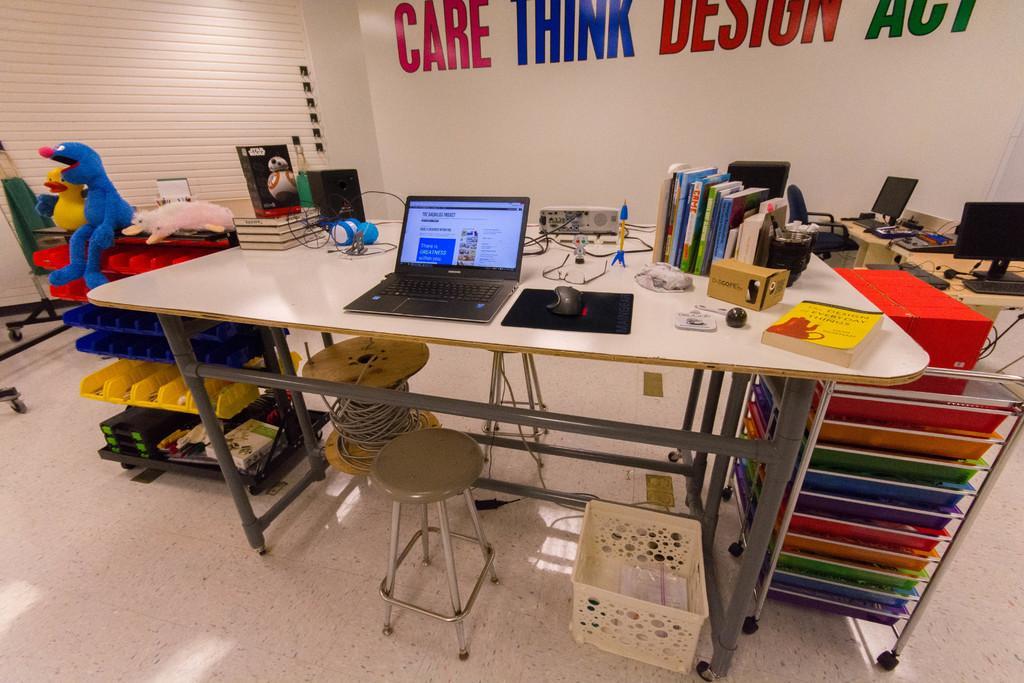Describe this image in one or two sentences. There is a table which consists of a laptop,mouse,books and a projector and also there is a toy beside the table and there are desktops in the right corner. 